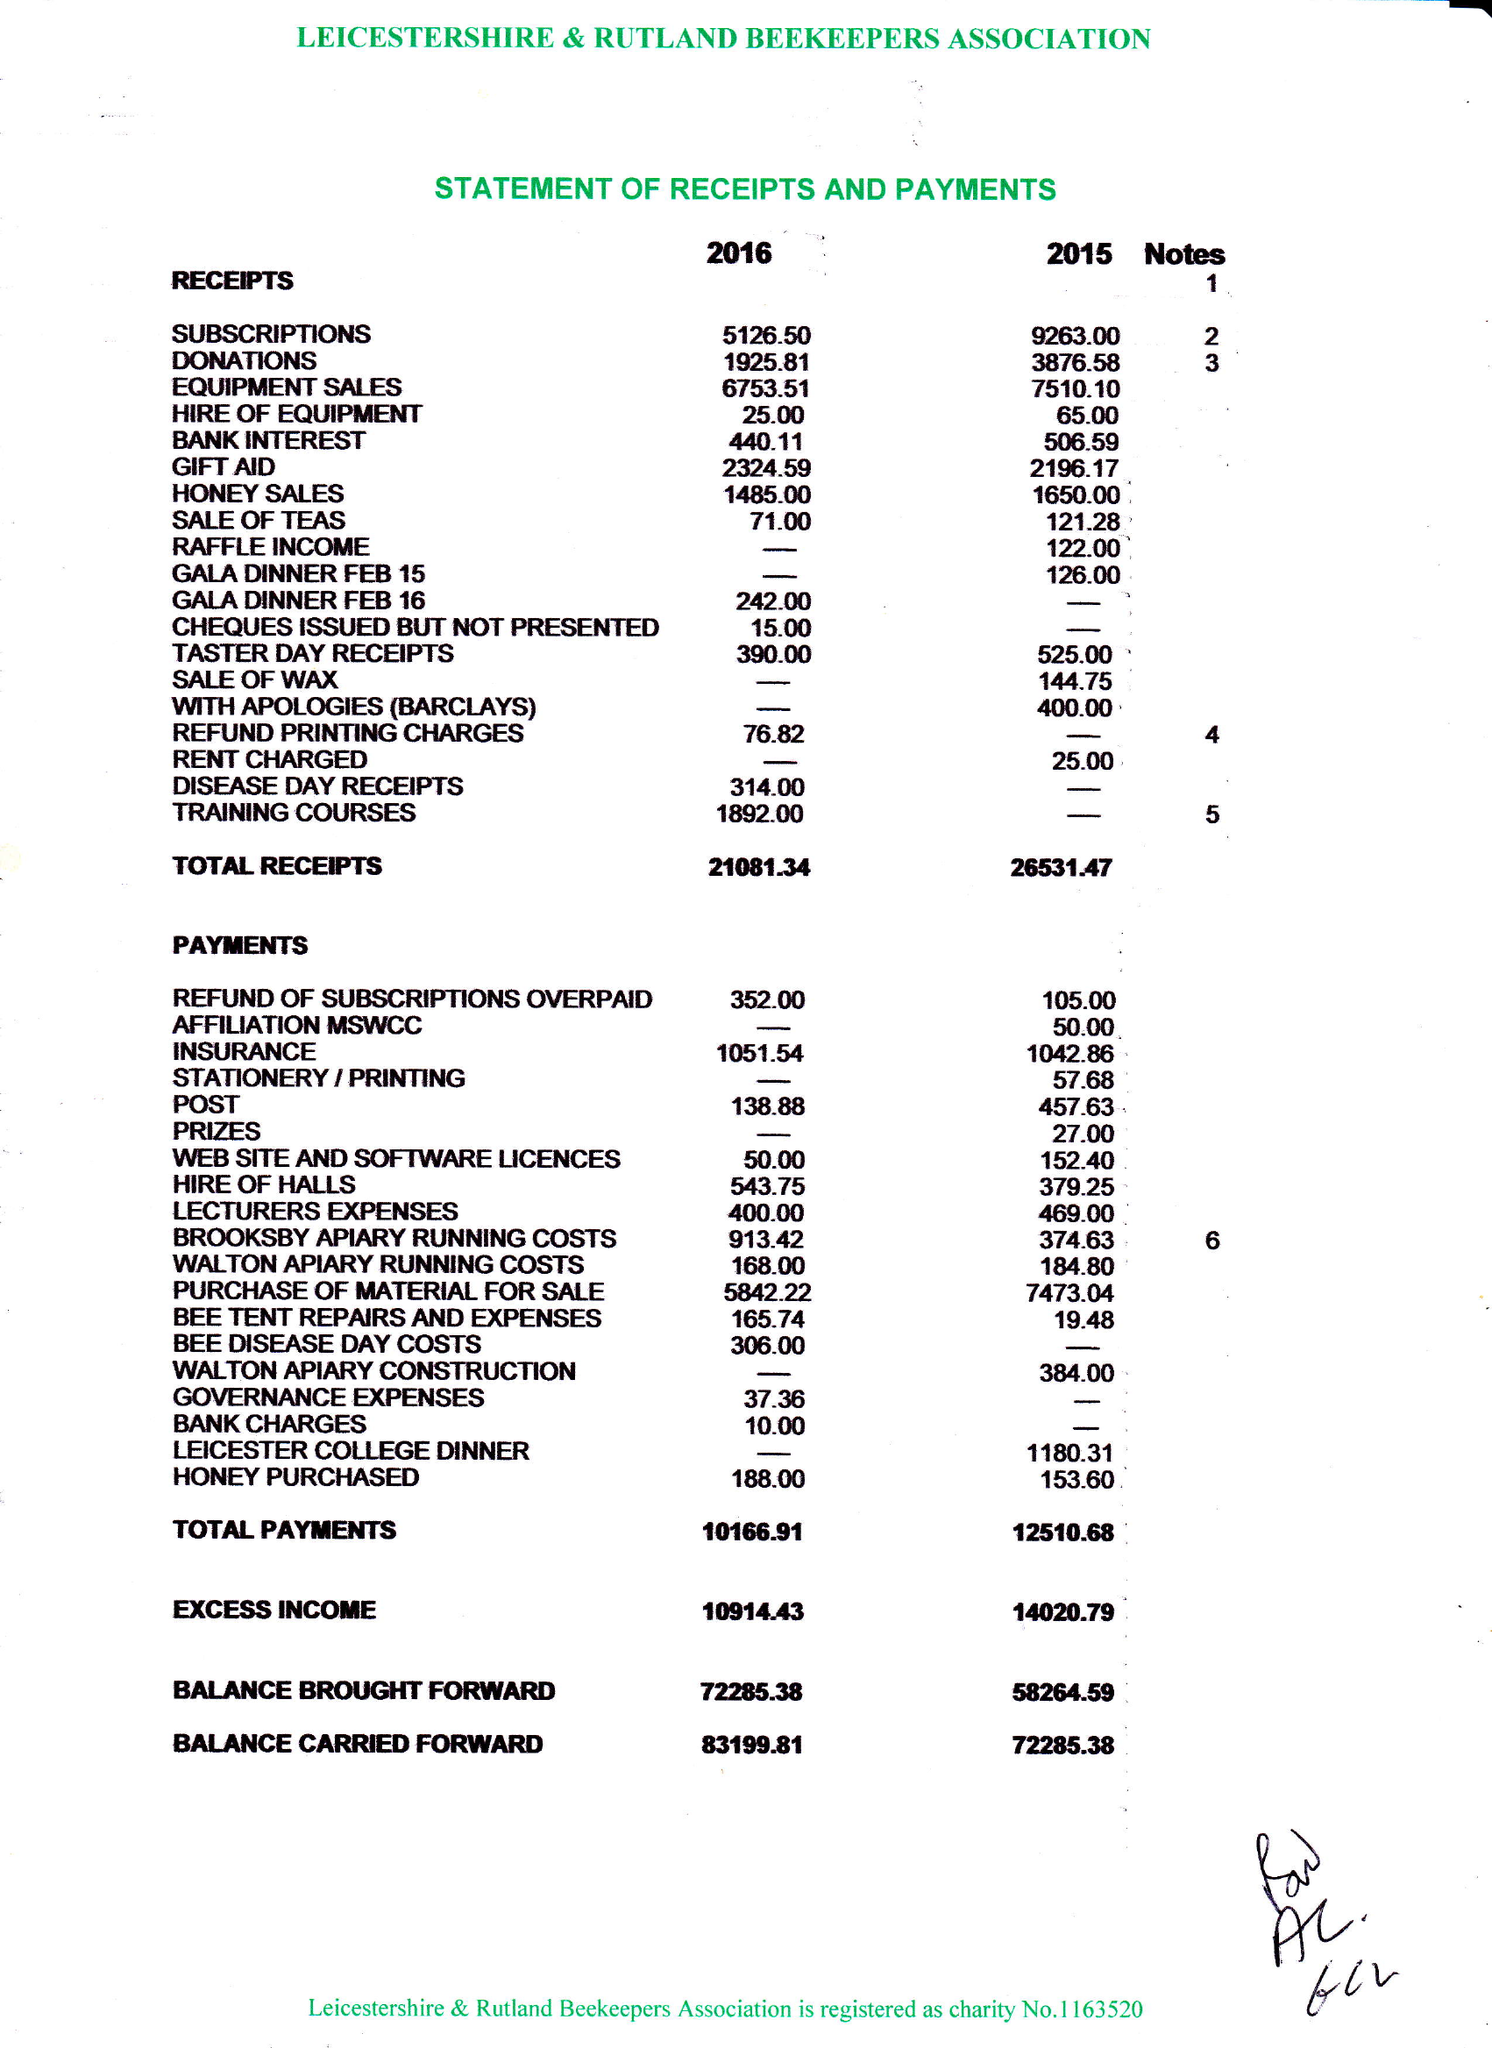What is the value for the income_annually_in_british_pounds?
Answer the question using a single word or phrase. 21081.00 